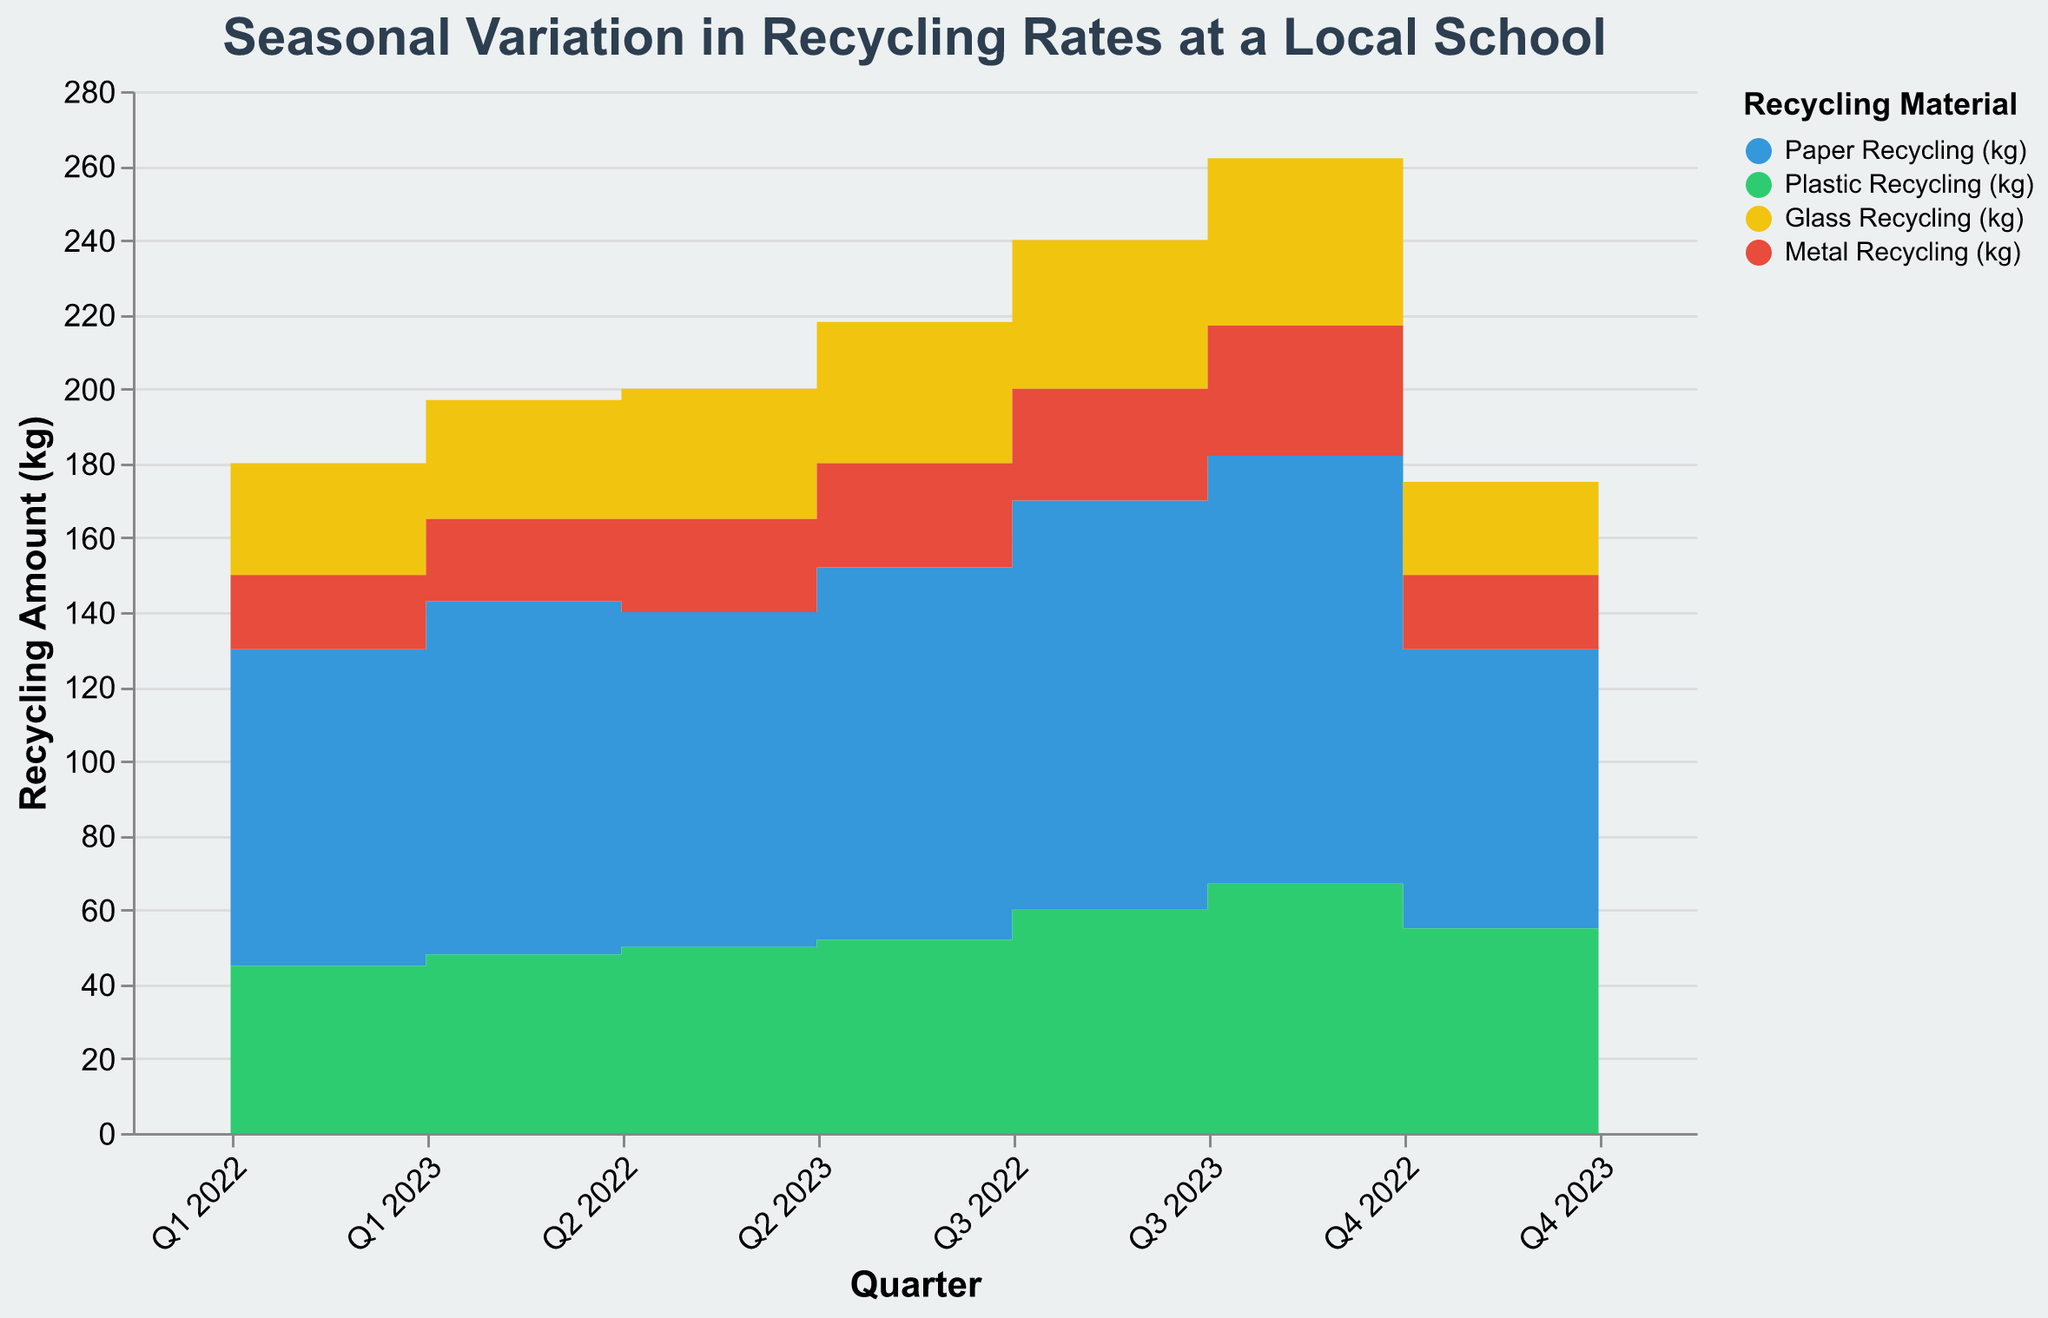What's the title of the chart? The title of the chart is displayed at the top and reads "Seasonal Variation in Recycling Rates at a Local School".
Answer: Seasonal Variation in Recycling Rates at a Local School Which material had the highest recycling amount in Q3 2023? In Q3 2023, the highest stacked area segment corresponds to the color representing "Paper Recycling (kg)".
Answer: Paper Recycling How much Metal recycling was recorded in Q3 2022 and Q3 2023 combined? The metal recycling amounts for Q3 2022 and Q3 2023 are 30 kg and 35 kg respectively. Adding them gives 30 + 35 = 65 kg.
Answer: 65 kg In which quarter of 2022 did Paper recycling peak? Looking at the height of the "Paper Recycling (kg)" area segment in 2022, Q3 2022 has the highest peak in the stack area chart.
Answer: Q3 2022 Compare the amount of Plastic recycling between Q4 2022 and Q4 2023. Which quarter saw more recycling? The Plastic recycling amount is represented by the green area. Q4 2023 has a higher green area segment than Q4 2022, so Q4 2023 saw more Plastic recycling.
Answer: Q4 2023 Compare the total recycling amount in Q1 2022 and Q1 2023. Which quarter had a higher total? Summing up all materials for Q1 2022: 85 (Paper) + 45 (Plastic) + 30 (Glass) + 20 (Metal) = 180 kg. For Q1 2023: 95 (Paper) + 48 (Plastic) + 32 (Glass) + 22 (Metal) = 197 kg. Comparing the totals, Q1 2023 had a higher total.
Answer: Q1 2023 Which material shows a consistent upward trend over the quarters displayed? The different materials are represented by different colored areas. The green area representing "Plastic Recycling (kg)" consistently increases over the quarters.
Answer: Plastic Recycling What is the average amount of Glass recycling per quarter in 2023? The Glass recycling amounts per quarter in 2023 are: Q1 - 32 kg, Q2 - 38 kg, Q3 - 45 kg, Q4 - 28 kg. Sum is 32 + 38 + 45 + 28 = 143 kg. The average is 143 kg / 4 = 35.75 kg.
Answer: 35.75 kg How does the Metal recycling in Q4 2022 compare to that in Q4 2023? Comparing the red area segments for Metal recycling in Q4 2022 and Q4 2023, both show the amount as 20 kg and 25 kg respectively. Therefore, Metal recycling increased by 5 kg from Q4 2022 to Q4 2023.
Answer: Q4 2023 had 5 kg more 